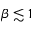<formula> <loc_0><loc_0><loc_500><loc_500>\beta \lesssim 1</formula> 